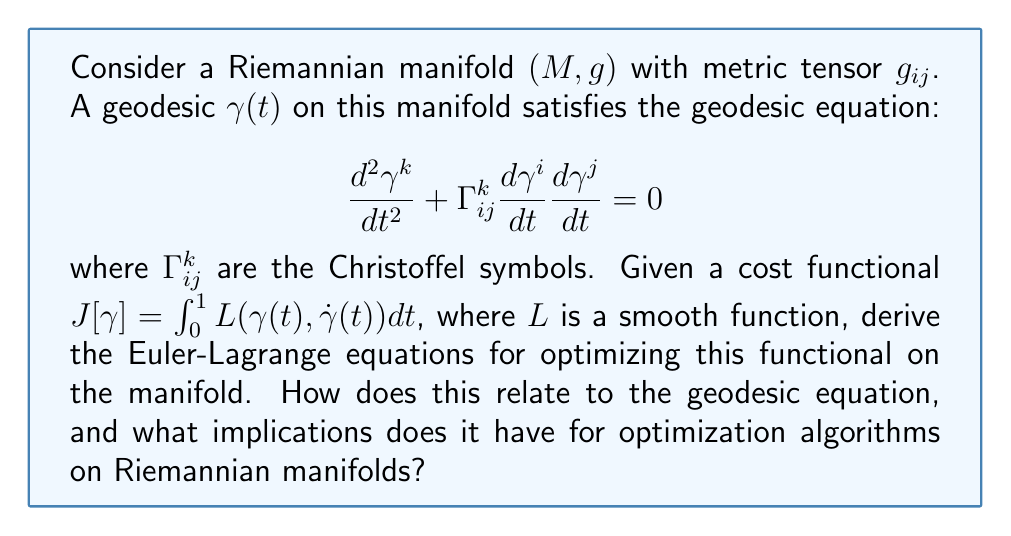Can you solve this math problem? To solve this problem, we'll follow these steps:

1) First, we recall the general form of the Euler-Lagrange equations for a functional $J[y] = \int_a^b L(t,y,\dot{y})dt$:

   $$\frac{\partial L}{\partial y} - \frac{d}{dt}\left(\frac{\partial L}{\partial \dot{y}}\right) = 0$$

2) In our case, we have $J[\gamma] = \int_0^1 L(\gamma(t), \dot{\gamma}(t)) dt$. Note that $\gamma(t)$ is a vector-valued function with components $\gamma^i(t)$.

3) Applying the Euler-Lagrange equations to each component $\gamma^k$:

   $$\frac{\partial L}{\partial \gamma^k} - \frac{d}{dt}\left(\frac{\partial L}{\partial \dot{\gamma}^k}\right) = 0$$

4) Now, we need to account for the Riemannian structure. The Lagrangian $L$ must be compatible with the metric $g_{ij}$. A natural choice is:

   $$L(\gamma, \dot{\gamma}) = \frac{1}{2}g_{ij}(\gamma)\dot{\gamma}^i\dot{\gamma}^j$$

5) Substituting this into our Euler-Lagrange equations:

   $$\frac{1}{2}\frac{\partial g_{ij}}{\partial \gamma^k}\dot{\gamma}^i\dot{\gamma}^j - \frac{d}{dt}(g_{kj}\dot{\gamma}^j) = 0$$

6) Expanding the time derivative:

   $$\frac{1}{2}\frac{\partial g_{ij}}{\partial \gamma^k}\dot{\gamma}^i\dot{\gamma}^j - \frac{\partial g_{kj}}{\partial \gamma^l}\dot{\gamma}^l\dot{\gamma}^j - g_{kj}\ddot{\gamma}^j = 0$$

7) Rearranging terms:

   $$g_{kj}\ddot{\gamma}^j + \frac{\partial g_{kj}}{\partial \gamma^l}\dot{\gamma}^l\dot{\gamma}^j - \frac{1}{2}\frac{\partial g_{ij}}{\partial \gamma^k}\dot{\gamma}^i\dot{\gamma}^j = 0$$

8) Recognizing that the Christoffel symbols can be expressed as:

   $$\Gamma^k_{ij} = \frac{1}{2}g^{kl}\left(\frac{\partial g_{il}}{\partial \gamma^j} + \frac{\partial g_{jl}}{\partial \gamma^i} - \frac{\partial g_{ij}}{\partial \gamma^l}\right)$$

9) We can rewrite our equation as:

   $$\ddot{\gamma}^k + \Gamma^k_{ij}\dot{\gamma}^i\dot{\gamma}^j = 0$$

This is precisely the geodesic equation we started with.

Implications for optimization algorithms:
1) The geodesics are locally length-minimizing curves on the manifold.
2) Optimization algorithms on Riemannian manifolds should respect the manifold's geometry, using geodesics for line searches or as acceleration directions.
3) Natural gradient descent and other Riemannian optimization methods use the manifold's metric to define steepest descent directions.
4) Second-order methods like Newton's method on manifolds use the exponential map to move along geodesics.
Answer: The Euler-Lagrange equations for optimizing $J[\gamma] = \int_0^1 L(\gamma(t), \dot{\gamma}(t)) dt$ on a Riemannian manifold yield the geodesic equation: $\ddot{\gamma}^k + \Gamma^k_{ij}\dot{\gamma}^i\dot{\gamma}^j = 0$. This implies that geodesics are optimal paths, guiding the design of Riemannian optimization algorithms. 